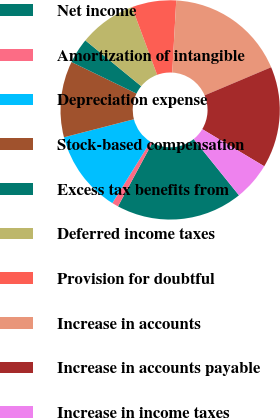Convert chart to OTSL. <chart><loc_0><loc_0><loc_500><loc_500><pie_chart><fcel>Net income<fcel>Amortization of intangible<fcel>Depreciation expense<fcel>Stock-based compensation<fcel>Excess tax benefits from<fcel>Deferred income taxes<fcel>Provision for doubtful<fcel>Increase in accounts<fcel>Increase in accounts payable<fcel>Increase in income taxes<nl><fcel>18.69%<fcel>0.94%<fcel>12.15%<fcel>11.21%<fcel>3.74%<fcel>8.41%<fcel>6.54%<fcel>17.75%<fcel>14.95%<fcel>5.61%<nl></chart> 